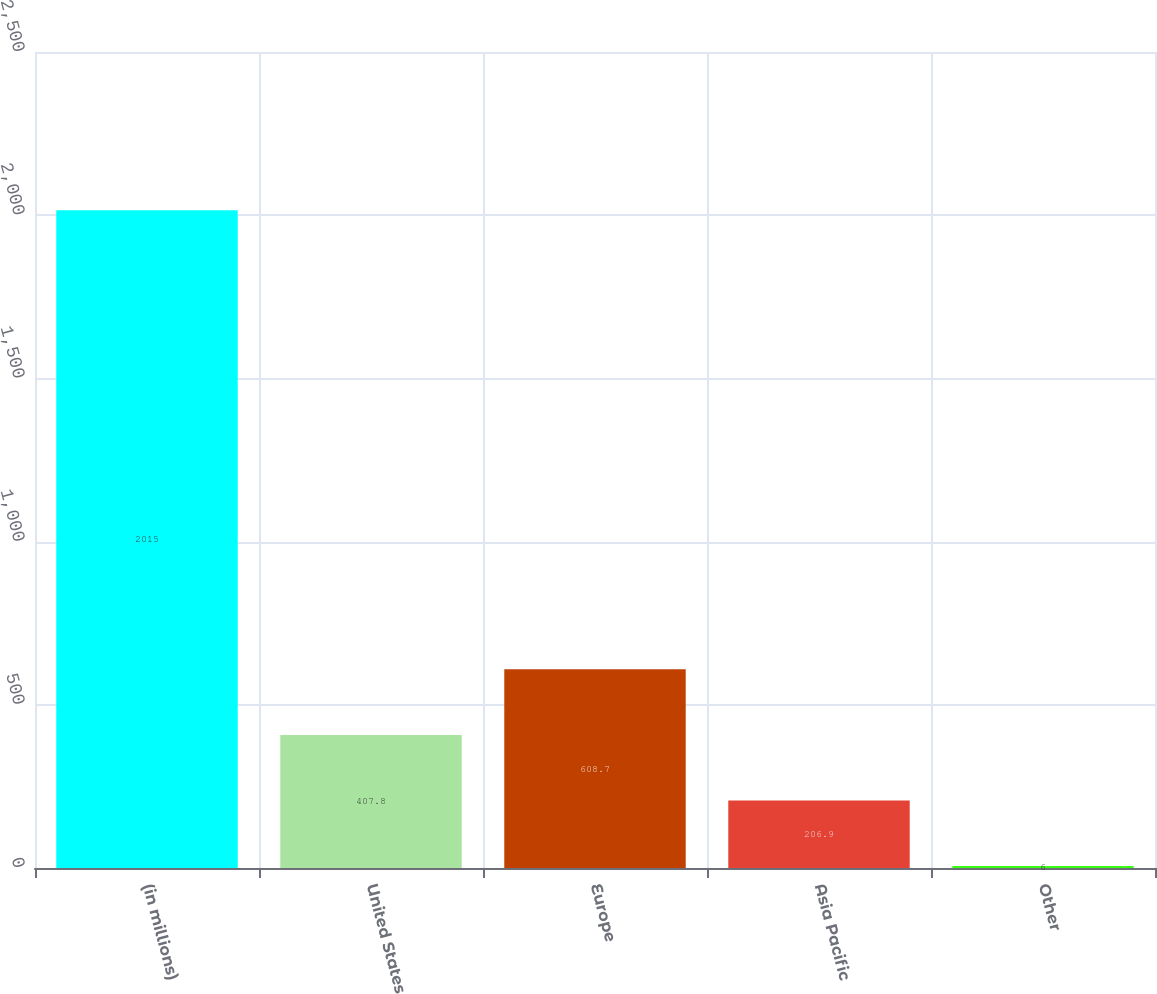Convert chart to OTSL. <chart><loc_0><loc_0><loc_500><loc_500><bar_chart><fcel>(in millions)<fcel>United States<fcel>Europe<fcel>Asia Pacific<fcel>Other<nl><fcel>2015<fcel>407.8<fcel>608.7<fcel>206.9<fcel>6<nl></chart> 